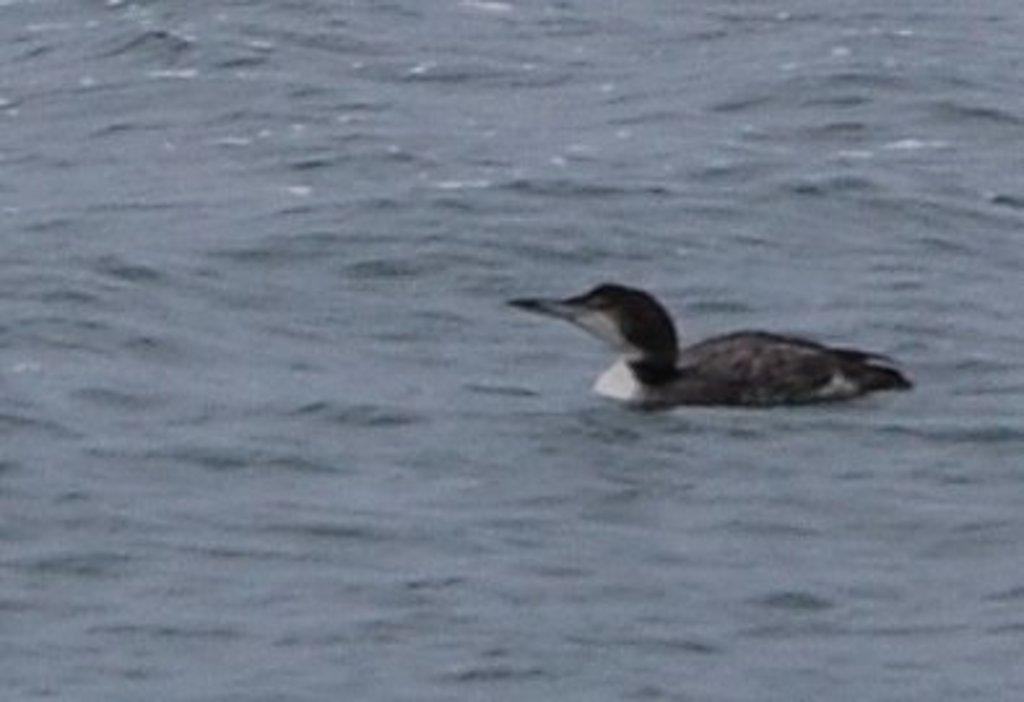What type of animal is present in the image? There is a bird in the image. What is the primary element in which the bird is situated? There is water in the image. Where is the bird's desk located in the image? There is no desk present in the image, and therefore no such location can be identified. 